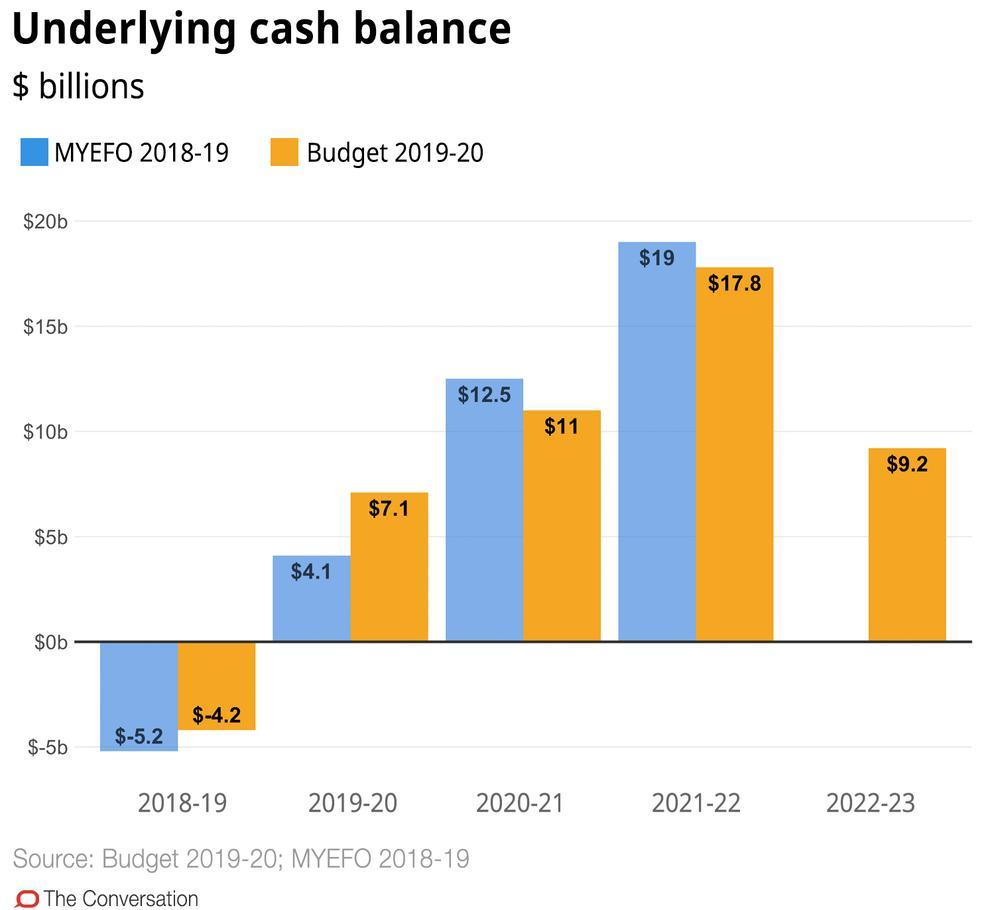What is the maximum value of MYEFO for the year 2021-22 in billion $?
Answer the question with a short phrase. $19 Which year did underlying cash balance for MYEFO  hit the lowest? 2018-19 What is the budget 2019-20 predicted for2022-23 in $ billions? $9.2 